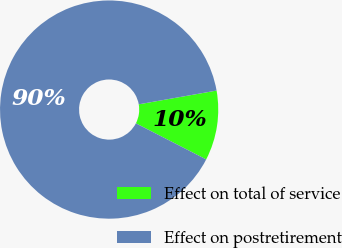<chart> <loc_0><loc_0><loc_500><loc_500><pie_chart><fcel>Effect on total of service<fcel>Effect on postretirement<nl><fcel>10.34%<fcel>89.66%<nl></chart> 